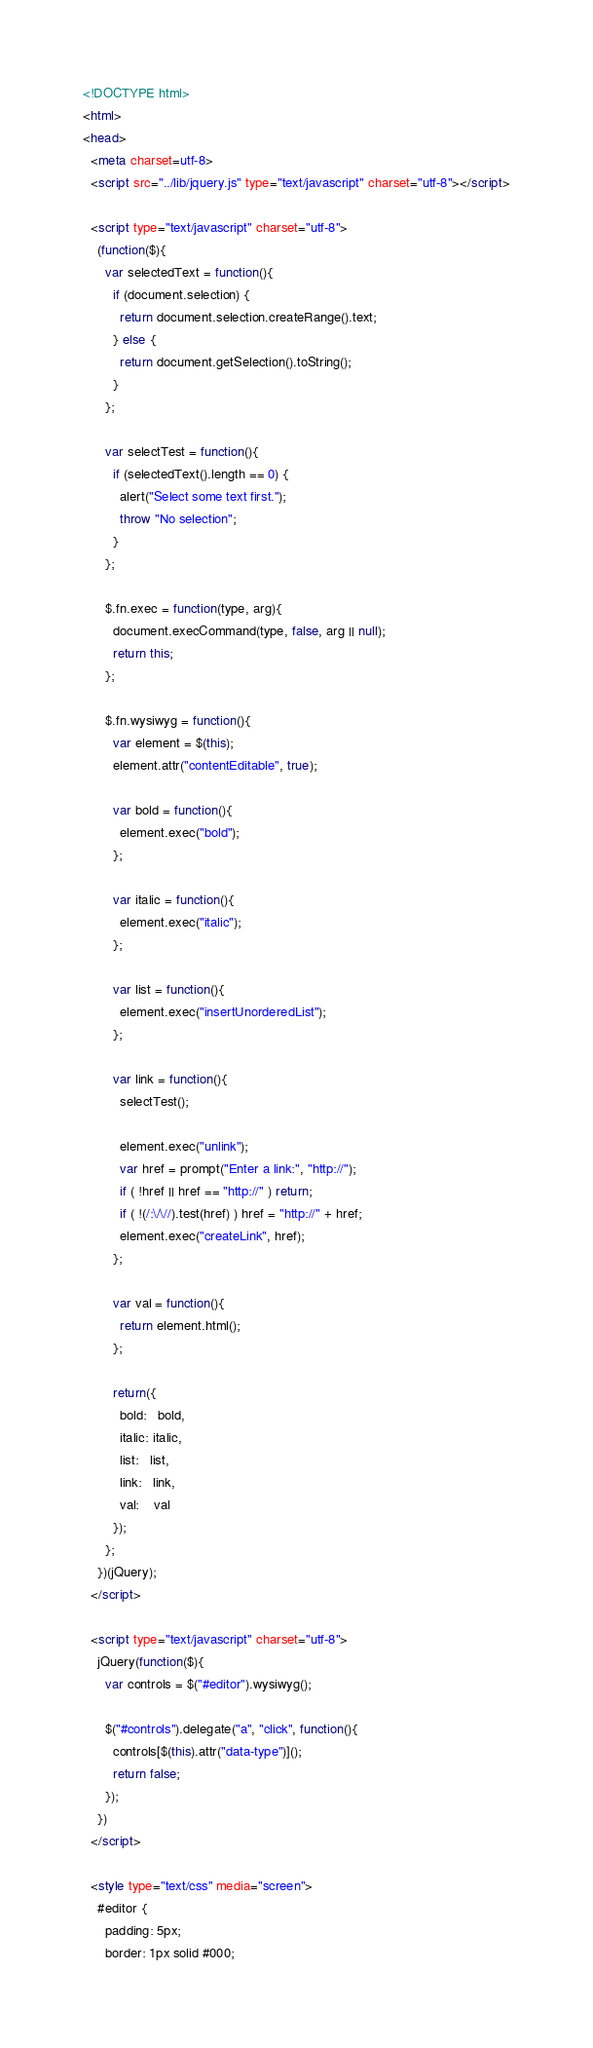<code> <loc_0><loc_0><loc_500><loc_500><_HTML_><!DOCTYPE html>
<html>
<head>
  <meta charset=utf-8>
  <script src="../lib/jquery.js" type="text/javascript" charset="utf-8"></script>
  
  <script type="text/javascript" charset="utf-8">
    (function($){
      var selectedText = function(){
        if (document.selection) {
          return document.selection.createRange().text;
        } else {
          return document.getSelection().toString();
        }
      };

      var selectTest = function(){
        if (selectedText().length == 0) {
          alert("Select some text first.");
          throw "No selection";
        }
      };

      $.fn.exec = function(type, arg){    
        document.execCommand(type, false, arg || null);
        return this;
      };

      $.fn.wysiwyg = function(){
        var element = $(this);
        element.attr("contentEditable", true);

        var bold = function(){
          element.exec("bold");
        };

        var italic = function(){
          element.exec("italic");
        };

        var list = function(){
          element.exec("insertUnorderedList");
        };

        var link = function(){
          selectTest();

          element.exec("unlink");
          var href = prompt("Enter a link:", "http://");
          if ( !href || href == "http://" ) return;
          if ( !(/:\/\//).test(href) ) href = "http://" + href;
          element.exec("createLink", href);
        };

        var val = function(){
          return element.html();
        };

        return({
          bold:   bold,
          italic: italic,
          list:   list,
          link:   link,
          val:    val
        });
      };
    })(jQuery);
  </script>
  
  <script type="text/javascript" charset="utf-8">
    jQuery(function($){
      var controls = $("#editor").wysiwyg();
      
      $("#controls").delegate("a", "click", function(){
        controls[$(this).attr("data-type")]();
        return false;
      });
    })
  </script>
  
  <style type="text/css" media="screen">
    #editor {
      padding: 5px;
      border: 1px solid #000;</code> 